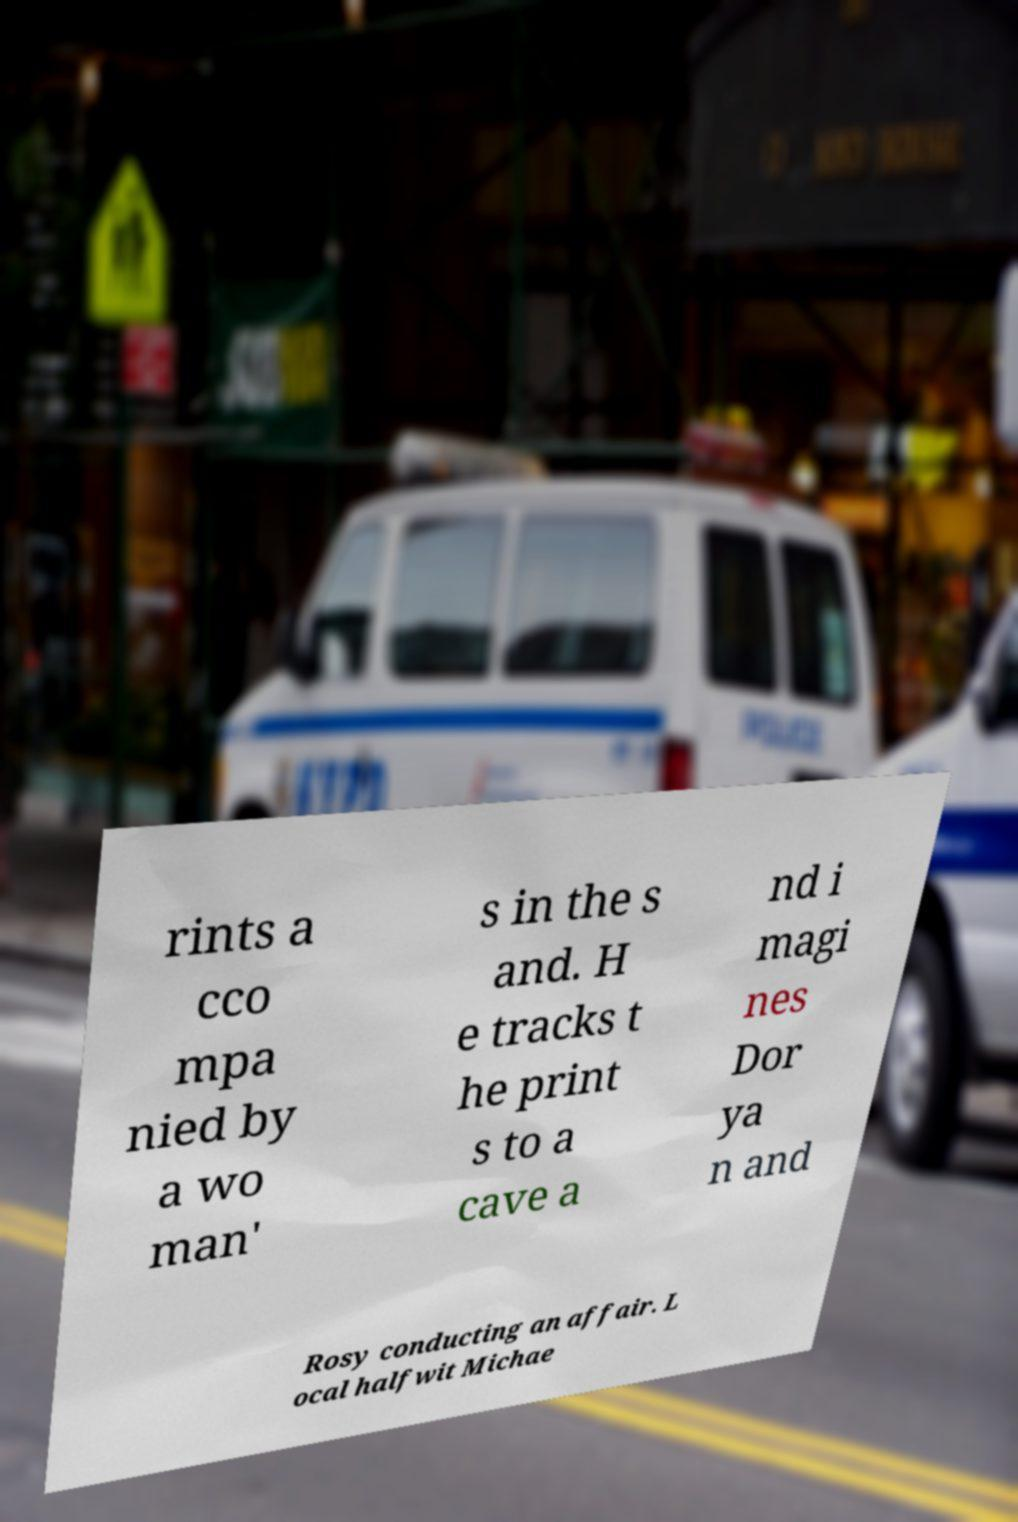Please identify and transcribe the text found in this image. rints a cco mpa nied by a wo man' s in the s and. H e tracks t he print s to a cave a nd i magi nes Dor ya n and Rosy conducting an affair. L ocal halfwit Michae 